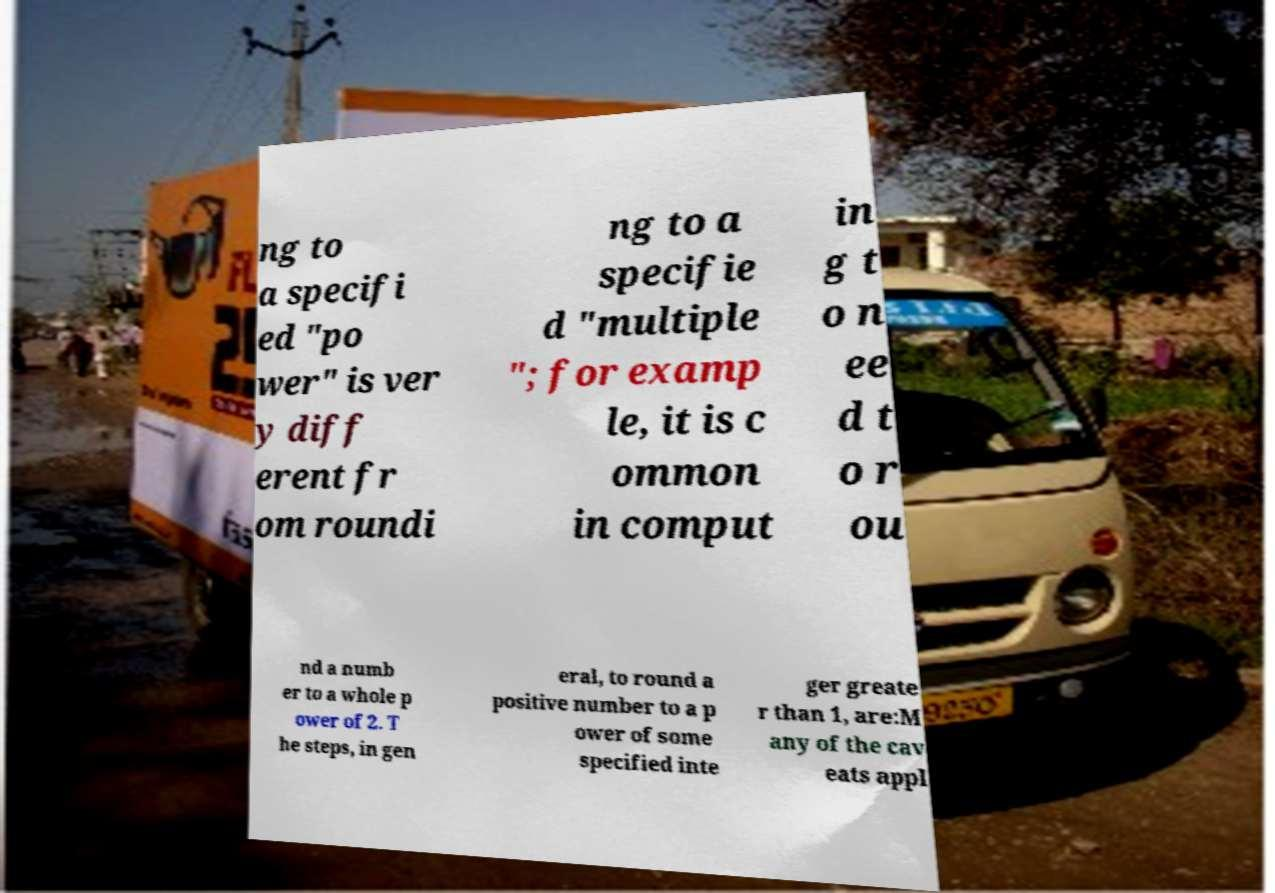Could you assist in decoding the text presented in this image and type it out clearly? ng to a specifi ed "po wer" is ver y diff erent fr om roundi ng to a specifie d "multiple "; for examp le, it is c ommon in comput in g t o n ee d t o r ou nd a numb er to a whole p ower of 2. T he steps, in gen eral, to round a positive number to a p ower of some specified inte ger greate r than 1, are:M any of the cav eats appl 